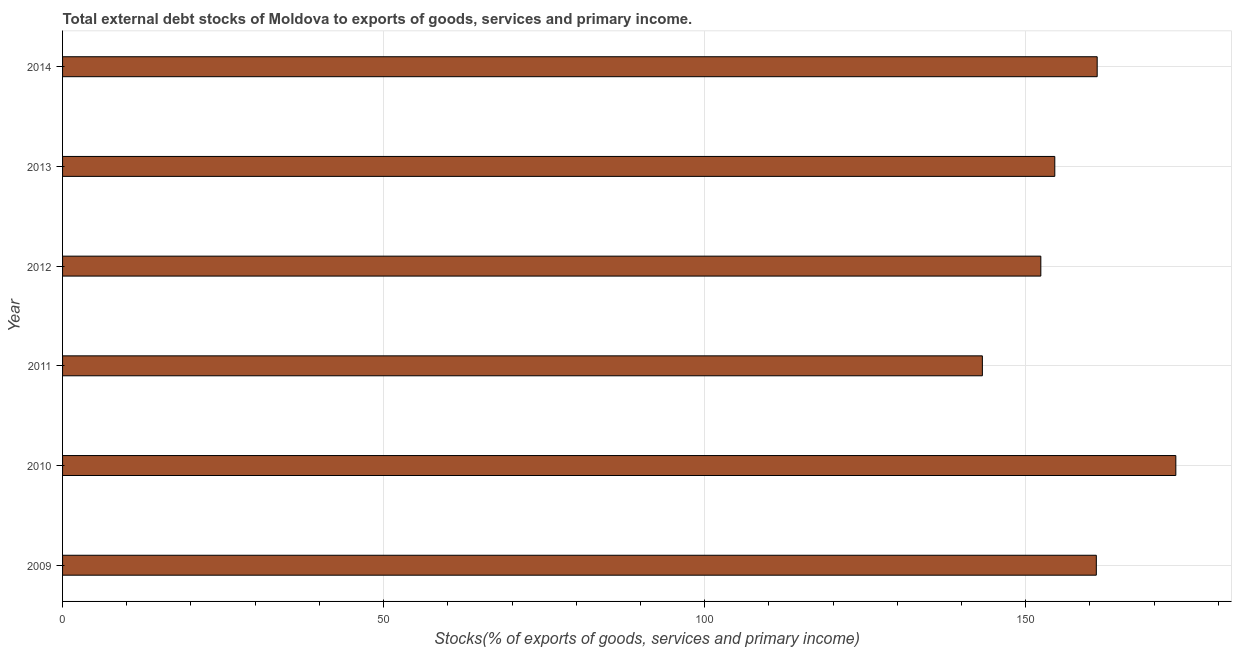What is the title of the graph?
Make the answer very short. Total external debt stocks of Moldova to exports of goods, services and primary income. What is the label or title of the X-axis?
Your response must be concise. Stocks(% of exports of goods, services and primary income). What is the external debt stocks in 2014?
Your answer should be very brief. 161.13. Across all years, what is the maximum external debt stocks?
Give a very brief answer. 173.37. Across all years, what is the minimum external debt stocks?
Give a very brief answer. 143.25. In which year was the external debt stocks maximum?
Provide a succinct answer. 2010. In which year was the external debt stocks minimum?
Provide a short and direct response. 2011. What is the sum of the external debt stocks?
Provide a succinct answer. 945.62. What is the difference between the external debt stocks in 2012 and 2013?
Your response must be concise. -2.18. What is the average external debt stocks per year?
Provide a succinct answer. 157.6. What is the median external debt stocks?
Your response must be concise. 157.76. In how many years, is the external debt stocks greater than 90 %?
Your response must be concise. 6. Is the difference between the external debt stocks in 2012 and 2013 greater than the difference between any two years?
Your response must be concise. No. What is the difference between the highest and the second highest external debt stocks?
Offer a terse response. 12.25. What is the difference between the highest and the lowest external debt stocks?
Your answer should be very brief. 30.13. Are all the bars in the graph horizontal?
Make the answer very short. Yes. How many years are there in the graph?
Provide a succinct answer. 6. What is the difference between two consecutive major ticks on the X-axis?
Offer a very short reply. 50. What is the Stocks(% of exports of goods, services and primary income) in 2009?
Provide a short and direct response. 160.99. What is the Stocks(% of exports of goods, services and primary income) in 2010?
Ensure brevity in your answer.  173.37. What is the Stocks(% of exports of goods, services and primary income) in 2011?
Ensure brevity in your answer.  143.25. What is the Stocks(% of exports of goods, services and primary income) of 2012?
Provide a short and direct response. 152.35. What is the Stocks(% of exports of goods, services and primary income) of 2013?
Keep it short and to the point. 154.53. What is the Stocks(% of exports of goods, services and primary income) of 2014?
Give a very brief answer. 161.13. What is the difference between the Stocks(% of exports of goods, services and primary income) in 2009 and 2010?
Your answer should be compact. -12.38. What is the difference between the Stocks(% of exports of goods, services and primary income) in 2009 and 2011?
Keep it short and to the point. 17.75. What is the difference between the Stocks(% of exports of goods, services and primary income) in 2009 and 2012?
Give a very brief answer. 8.64. What is the difference between the Stocks(% of exports of goods, services and primary income) in 2009 and 2013?
Your answer should be compact. 6.47. What is the difference between the Stocks(% of exports of goods, services and primary income) in 2009 and 2014?
Give a very brief answer. -0.13. What is the difference between the Stocks(% of exports of goods, services and primary income) in 2010 and 2011?
Offer a very short reply. 30.13. What is the difference between the Stocks(% of exports of goods, services and primary income) in 2010 and 2012?
Give a very brief answer. 21.02. What is the difference between the Stocks(% of exports of goods, services and primary income) in 2010 and 2013?
Keep it short and to the point. 18.85. What is the difference between the Stocks(% of exports of goods, services and primary income) in 2010 and 2014?
Provide a short and direct response. 12.25. What is the difference between the Stocks(% of exports of goods, services and primary income) in 2011 and 2012?
Provide a short and direct response. -9.1. What is the difference between the Stocks(% of exports of goods, services and primary income) in 2011 and 2013?
Your response must be concise. -11.28. What is the difference between the Stocks(% of exports of goods, services and primary income) in 2011 and 2014?
Make the answer very short. -17.88. What is the difference between the Stocks(% of exports of goods, services and primary income) in 2012 and 2013?
Your response must be concise. -2.18. What is the difference between the Stocks(% of exports of goods, services and primary income) in 2012 and 2014?
Offer a terse response. -8.78. What is the difference between the Stocks(% of exports of goods, services and primary income) in 2013 and 2014?
Provide a short and direct response. -6.6. What is the ratio of the Stocks(% of exports of goods, services and primary income) in 2009 to that in 2010?
Ensure brevity in your answer.  0.93. What is the ratio of the Stocks(% of exports of goods, services and primary income) in 2009 to that in 2011?
Your answer should be very brief. 1.12. What is the ratio of the Stocks(% of exports of goods, services and primary income) in 2009 to that in 2012?
Ensure brevity in your answer.  1.06. What is the ratio of the Stocks(% of exports of goods, services and primary income) in 2009 to that in 2013?
Offer a terse response. 1.04. What is the ratio of the Stocks(% of exports of goods, services and primary income) in 2010 to that in 2011?
Your answer should be compact. 1.21. What is the ratio of the Stocks(% of exports of goods, services and primary income) in 2010 to that in 2012?
Offer a terse response. 1.14. What is the ratio of the Stocks(% of exports of goods, services and primary income) in 2010 to that in 2013?
Offer a terse response. 1.12. What is the ratio of the Stocks(% of exports of goods, services and primary income) in 2010 to that in 2014?
Your answer should be very brief. 1.08. What is the ratio of the Stocks(% of exports of goods, services and primary income) in 2011 to that in 2012?
Offer a terse response. 0.94. What is the ratio of the Stocks(% of exports of goods, services and primary income) in 2011 to that in 2013?
Offer a very short reply. 0.93. What is the ratio of the Stocks(% of exports of goods, services and primary income) in 2011 to that in 2014?
Provide a succinct answer. 0.89. What is the ratio of the Stocks(% of exports of goods, services and primary income) in 2012 to that in 2014?
Your answer should be very brief. 0.95. What is the ratio of the Stocks(% of exports of goods, services and primary income) in 2013 to that in 2014?
Keep it short and to the point. 0.96. 